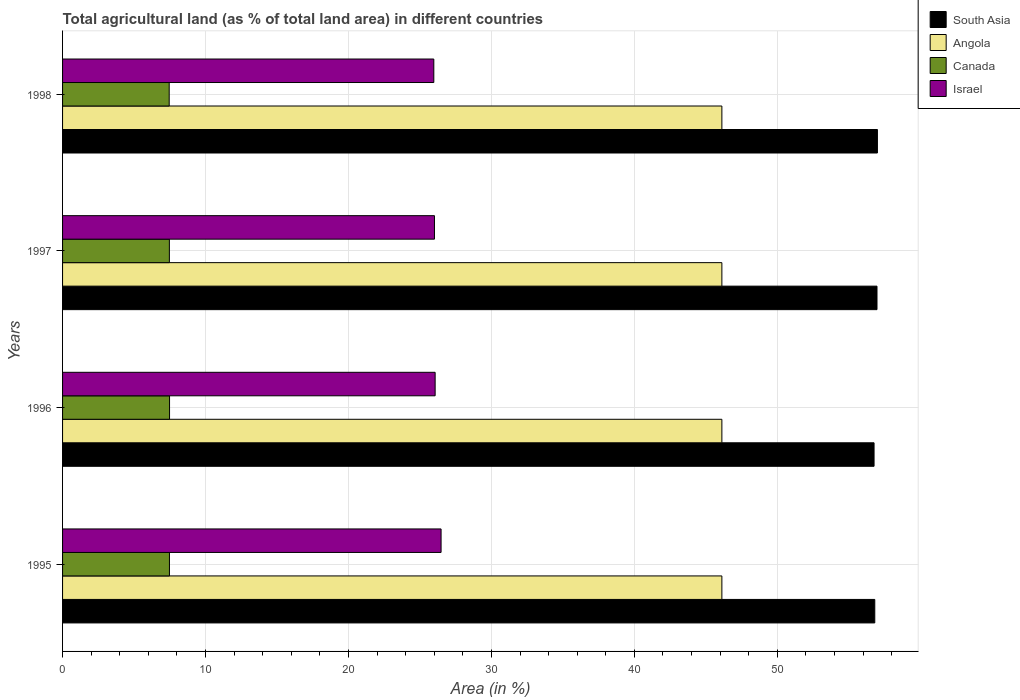How many different coloured bars are there?
Ensure brevity in your answer.  4. Are the number of bars per tick equal to the number of legend labels?
Offer a very short reply. Yes. How many bars are there on the 2nd tick from the top?
Make the answer very short. 4. In how many cases, is the number of bars for a given year not equal to the number of legend labels?
Give a very brief answer. 0. What is the percentage of agricultural land in Israel in 1995?
Your answer should be compact. 26.48. Across all years, what is the maximum percentage of agricultural land in Angola?
Make the answer very short. 46.12. Across all years, what is the minimum percentage of agricultural land in South Asia?
Ensure brevity in your answer.  56.77. In which year was the percentage of agricultural land in Angola maximum?
Keep it short and to the point. 1995. In which year was the percentage of agricultural land in Angola minimum?
Provide a short and direct response. 1995. What is the total percentage of agricultural land in Angola in the graph?
Give a very brief answer. 184.49. What is the difference between the percentage of agricultural land in Canada in 1996 and that in 1997?
Offer a very short reply. 0.01. What is the difference between the percentage of agricultural land in South Asia in 1995 and the percentage of agricultural land in Canada in 1997?
Ensure brevity in your answer.  49.35. What is the average percentage of agricultural land in Canada per year?
Offer a very short reply. 7.47. In the year 1997, what is the difference between the percentage of agricultural land in Israel and percentage of agricultural land in Canada?
Provide a succinct answer. 18.54. What is the difference between the highest and the second highest percentage of agricultural land in Israel?
Your response must be concise. 0.42. Does the graph contain any zero values?
Provide a short and direct response. No. Does the graph contain grids?
Give a very brief answer. Yes. Where does the legend appear in the graph?
Make the answer very short. Top right. What is the title of the graph?
Offer a terse response. Total agricultural land (as % of total land area) in different countries. What is the label or title of the X-axis?
Offer a terse response. Area (in %). What is the Area (in %) of South Asia in 1995?
Offer a very short reply. 56.82. What is the Area (in %) in Angola in 1995?
Give a very brief answer. 46.12. What is the Area (in %) in Canada in 1995?
Keep it short and to the point. 7.48. What is the Area (in %) of Israel in 1995?
Your answer should be very brief. 26.48. What is the Area (in %) of South Asia in 1996?
Offer a very short reply. 56.77. What is the Area (in %) of Angola in 1996?
Make the answer very short. 46.12. What is the Area (in %) in Canada in 1996?
Ensure brevity in your answer.  7.48. What is the Area (in %) in Israel in 1996?
Give a very brief answer. 26.06. What is the Area (in %) of South Asia in 1997?
Offer a very short reply. 56.97. What is the Area (in %) in Angola in 1997?
Offer a terse response. 46.12. What is the Area (in %) in Canada in 1997?
Offer a terse response. 7.47. What is the Area (in %) in Israel in 1997?
Your answer should be very brief. 26.02. What is the Area (in %) in South Asia in 1998?
Your answer should be compact. 57. What is the Area (in %) in Angola in 1998?
Provide a short and direct response. 46.12. What is the Area (in %) in Canada in 1998?
Your answer should be very brief. 7.46. What is the Area (in %) in Israel in 1998?
Make the answer very short. 25.97. Across all years, what is the maximum Area (in %) of South Asia?
Offer a terse response. 57. Across all years, what is the maximum Area (in %) in Angola?
Keep it short and to the point. 46.12. Across all years, what is the maximum Area (in %) in Canada?
Provide a succinct answer. 7.48. Across all years, what is the maximum Area (in %) of Israel?
Make the answer very short. 26.48. Across all years, what is the minimum Area (in %) in South Asia?
Offer a terse response. 56.77. Across all years, what is the minimum Area (in %) of Angola?
Your answer should be compact. 46.12. Across all years, what is the minimum Area (in %) in Canada?
Give a very brief answer. 7.46. Across all years, what is the minimum Area (in %) of Israel?
Offer a terse response. 25.97. What is the total Area (in %) in South Asia in the graph?
Provide a succinct answer. 227.56. What is the total Area (in %) of Angola in the graph?
Make the answer very short. 184.49. What is the total Area (in %) of Canada in the graph?
Make the answer very short. 29.89. What is the total Area (in %) in Israel in the graph?
Your response must be concise. 104.53. What is the difference between the Area (in %) in South Asia in 1995 and that in 1996?
Keep it short and to the point. 0.05. What is the difference between the Area (in %) in Canada in 1995 and that in 1996?
Ensure brevity in your answer.  -0.01. What is the difference between the Area (in %) of Israel in 1995 and that in 1996?
Offer a very short reply. 0.42. What is the difference between the Area (in %) in South Asia in 1995 and that in 1997?
Your answer should be very brief. -0.15. What is the difference between the Area (in %) of Angola in 1995 and that in 1997?
Offer a very short reply. 0. What is the difference between the Area (in %) in Canada in 1995 and that in 1997?
Offer a very short reply. 0.01. What is the difference between the Area (in %) of Israel in 1995 and that in 1997?
Provide a succinct answer. 0.46. What is the difference between the Area (in %) in South Asia in 1995 and that in 1998?
Keep it short and to the point. -0.18. What is the difference between the Area (in %) of Canada in 1995 and that in 1998?
Your answer should be compact. 0.02. What is the difference between the Area (in %) of Israel in 1995 and that in 1998?
Your response must be concise. 0.51. What is the difference between the Area (in %) in South Asia in 1996 and that in 1997?
Your answer should be very brief. -0.21. What is the difference between the Area (in %) in Canada in 1996 and that in 1997?
Your answer should be very brief. 0.01. What is the difference between the Area (in %) in Israel in 1996 and that in 1997?
Your answer should be compact. 0.05. What is the difference between the Area (in %) in South Asia in 1996 and that in 1998?
Provide a short and direct response. -0.23. What is the difference between the Area (in %) in Angola in 1996 and that in 1998?
Ensure brevity in your answer.  0. What is the difference between the Area (in %) of Canada in 1996 and that in 1998?
Your answer should be compact. 0.02. What is the difference between the Area (in %) in Israel in 1996 and that in 1998?
Keep it short and to the point. 0.09. What is the difference between the Area (in %) of South Asia in 1997 and that in 1998?
Ensure brevity in your answer.  -0.03. What is the difference between the Area (in %) in Canada in 1997 and that in 1998?
Provide a short and direct response. 0.01. What is the difference between the Area (in %) in Israel in 1997 and that in 1998?
Provide a short and direct response. 0.05. What is the difference between the Area (in %) of South Asia in 1995 and the Area (in %) of Angola in 1996?
Your answer should be compact. 10.7. What is the difference between the Area (in %) of South Asia in 1995 and the Area (in %) of Canada in 1996?
Your answer should be compact. 49.33. What is the difference between the Area (in %) of South Asia in 1995 and the Area (in %) of Israel in 1996?
Offer a terse response. 30.76. What is the difference between the Area (in %) of Angola in 1995 and the Area (in %) of Canada in 1996?
Give a very brief answer. 38.64. What is the difference between the Area (in %) in Angola in 1995 and the Area (in %) in Israel in 1996?
Your answer should be very brief. 20.06. What is the difference between the Area (in %) in Canada in 1995 and the Area (in %) in Israel in 1996?
Your answer should be very brief. -18.59. What is the difference between the Area (in %) of South Asia in 1995 and the Area (in %) of Angola in 1997?
Make the answer very short. 10.7. What is the difference between the Area (in %) of South Asia in 1995 and the Area (in %) of Canada in 1997?
Ensure brevity in your answer.  49.35. What is the difference between the Area (in %) of South Asia in 1995 and the Area (in %) of Israel in 1997?
Keep it short and to the point. 30.8. What is the difference between the Area (in %) of Angola in 1995 and the Area (in %) of Canada in 1997?
Your answer should be very brief. 38.65. What is the difference between the Area (in %) of Angola in 1995 and the Area (in %) of Israel in 1997?
Give a very brief answer. 20.11. What is the difference between the Area (in %) of Canada in 1995 and the Area (in %) of Israel in 1997?
Provide a succinct answer. -18.54. What is the difference between the Area (in %) of South Asia in 1995 and the Area (in %) of Angola in 1998?
Provide a succinct answer. 10.7. What is the difference between the Area (in %) of South Asia in 1995 and the Area (in %) of Canada in 1998?
Provide a short and direct response. 49.36. What is the difference between the Area (in %) of South Asia in 1995 and the Area (in %) of Israel in 1998?
Your answer should be compact. 30.85. What is the difference between the Area (in %) of Angola in 1995 and the Area (in %) of Canada in 1998?
Keep it short and to the point. 38.66. What is the difference between the Area (in %) in Angola in 1995 and the Area (in %) in Israel in 1998?
Give a very brief answer. 20.15. What is the difference between the Area (in %) of Canada in 1995 and the Area (in %) of Israel in 1998?
Offer a terse response. -18.49. What is the difference between the Area (in %) of South Asia in 1996 and the Area (in %) of Angola in 1997?
Offer a very short reply. 10.65. What is the difference between the Area (in %) in South Asia in 1996 and the Area (in %) in Canada in 1997?
Keep it short and to the point. 49.3. What is the difference between the Area (in %) of South Asia in 1996 and the Area (in %) of Israel in 1997?
Provide a short and direct response. 30.75. What is the difference between the Area (in %) of Angola in 1996 and the Area (in %) of Canada in 1997?
Your answer should be very brief. 38.65. What is the difference between the Area (in %) of Angola in 1996 and the Area (in %) of Israel in 1997?
Keep it short and to the point. 20.11. What is the difference between the Area (in %) in Canada in 1996 and the Area (in %) in Israel in 1997?
Give a very brief answer. -18.53. What is the difference between the Area (in %) in South Asia in 1996 and the Area (in %) in Angola in 1998?
Make the answer very short. 10.65. What is the difference between the Area (in %) of South Asia in 1996 and the Area (in %) of Canada in 1998?
Keep it short and to the point. 49.31. What is the difference between the Area (in %) of South Asia in 1996 and the Area (in %) of Israel in 1998?
Ensure brevity in your answer.  30.8. What is the difference between the Area (in %) of Angola in 1996 and the Area (in %) of Canada in 1998?
Your response must be concise. 38.66. What is the difference between the Area (in %) in Angola in 1996 and the Area (in %) in Israel in 1998?
Your answer should be very brief. 20.15. What is the difference between the Area (in %) in Canada in 1996 and the Area (in %) in Israel in 1998?
Offer a very short reply. -18.49. What is the difference between the Area (in %) in South Asia in 1997 and the Area (in %) in Angola in 1998?
Your answer should be very brief. 10.85. What is the difference between the Area (in %) in South Asia in 1997 and the Area (in %) in Canada in 1998?
Provide a succinct answer. 49.51. What is the difference between the Area (in %) of South Asia in 1997 and the Area (in %) of Israel in 1998?
Offer a terse response. 31. What is the difference between the Area (in %) of Angola in 1997 and the Area (in %) of Canada in 1998?
Make the answer very short. 38.66. What is the difference between the Area (in %) of Angola in 1997 and the Area (in %) of Israel in 1998?
Your answer should be compact. 20.15. What is the difference between the Area (in %) of Canada in 1997 and the Area (in %) of Israel in 1998?
Ensure brevity in your answer.  -18.5. What is the average Area (in %) of South Asia per year?
Give a very brief answer. 56.89. What is the average Area (in %) of Angola per year?
Provide a short and direct response. 46.12. What is the average Area (in %) in Canada per year?
Give a very brief answer. 7.47. What is the average Area (in %) of Israel per year?
Your response must be concise. 26.13. In the year 1995, what is the difference between the Area (in %) of South Asia and Area (in %) of Angola?
Your answer should be compact. 10.7. In the year 1995, what is the difference between the Area (in %) in South Asia and Area (in %) in Canada?
Your response must be concise. 49.34. In the year 1995, what is the difference between the Area (in %) in South Asia and Area (in %) in Israel?
Provide a succinct answer. 30.34. In the year 1995, what is the difference between the Area (in %) of Angola and Area (in %) of Canada?
Keep it short and to the point. 38.64. In the year 1995, what is the difference between the Area (in %) of Angola and Area (in %) of Israel?
Make the answer very short. 19.64. In the year 1995, what is the difference between the Area (in %) in Canada and Area (in %) in Israel?
Your answer should be compact. -19. In the year 1996, what is the difference between the Area (in %) of South Asia and Area (in %) of Angola?
Your answer should be compact. 10.65. In the year 1996, what is the difference between the Area (in %) of South Asia and Area (in %) of Canada?
Make the answer very short. 49.28. In the year 1996, what is the difference between the Area (in %) in South Asia and Area (in %) in Israel?
Ensure brevity in your answer.  30.7. In the year 1996, what is the difference between the Area (in %) in Angola and Area (in %) in Canada?
Your answer should be very brief. 38.64. In the year 1996, what is the difference between the Area (in %) in Angola and Area (in %) in Israel?
Keep it short and to the point. 20.06. In the year 1996, what is the difference between the Area (in %) of Canada and Area (in %) of Israel?
Offer a very short reply. -18.58. In the year 1997, what is the difference between the Area (in %) of South Asia and Area (in %) of Angola?
Provide a succinct answer. 10.85. In the year 1997, what is the difference between the Area (in %) in South Asia and Area (in %) in Canada?
Your answer should be very brief. 49.5. In the year 1997, what is the difference between the Area (in %) in South Asia and Area (in %) in Israel?
Ensure brevity in your answer.  30.96. In the year 1997, what is the difference between the Area (in %) of Angola and Area (in %) of Canada?
Your response must be concise. 38.65. In the year 1997, what is the difference between the Area (in %) of Angola and Area (in %) of Israel?
Your answer should be compact. 20.11. In the year 1997, what is the difference between the Area (in %) in Canada and Area (in %) in Israel?
Offer a very short reply. -18.54. In the year 1998, what is the difference between the Area (in %) of South Asia and Area (in %) of Angola?
Provide a succinct answer. 10.88. In the year 1998, what is the difference between the Area (in %) in South Asia and Area (in %) in Canada?
Offer a very short reply. 49.54. In the year 1998, what is the difference between the Area (in %) of South Asia and Area (in %) of Israel?
Your answer should be compact. 31.03. In the year 1998, what is the difference between the Area (in %) of Angola and Area (in %) of Canada?
Your answer should be very brief. 38.66. In the year 1998, what is the difference between the Area (in %) of Angola and Area (in %) of Israel?
Ensure brevity in your answer.  20.15. In the year 1998, what is the difference between the Area (in %) in Canada and Area (in %) in Israel?
Provide a succinct answer. -18.51. What is the ratio of the Area (in %) in South Asia in 1995 to that in 1996?
Keep it short and to the point. 1. What is the ratio of the Area (in %) in Angola in 1995 to that in 1996?
Ensure brevity in your answer.  1. What is the ratio of the Area (in %) in Canada in 1995 to that in 1996?
Provide a succinct answer. 1. What is the ratio of the Area (in %) in Angola in 1995 to that in 1997?
Give a very brief answer. 1. What is the ratio of the Area (in %) in Canada in 1995 to that in 1997?
Provide a succinct answer. 1. What is the ratio of the Area (in %) of Israel in 1995 to that in 1997?
Ensure brevity in your answer.  1.02. What is the ratio of the Area (in %) of Canada in 1995 to that in 1998?
Keep it short and to the point. 1. What is the ratio of the Area (in %) of Israel in 1995 to that in 1998?
Your response must be concise. 1.02. What is the ratio of the Area (in %) in Israel in 1996 to that in 1997?
Your answer should be very brief. 1. What is the ratio of the Area (in %) in Israel in 1996 to that in 1998?
Ensure brevity in your answer.  1. What is the ratio of the Area (in %) in South Asia in 1997 to that in 1998?
Ensure brevity in your answer.  1. What is the ratio of the Area (in %) in Angola in 1997 to that in 1998?
Ensure brevity in your answer.  1. What is the ratio of the Area (in %) in Canada in 1997 to that in 1998?
Your response must be concise. 1. What is the ratio of the Area (in %) of Israel in 1997 to that in 1998?
Your response must be concise. 1. What is the difference between the highest and the second highest Area (in %) of South Asia?
Offer a terse response. 0.03. What is the difference between the highest and the second highest Area (in %) of Canada?
Make the answer very short. 0.01. What is the difference between the highest and the second highest Area (in %) in Israel?
Provide a short and direct response. 0.42. What is the difference between the highest and the lowest Area (in %) in South Asia?
Offer a very short reply. 0.23. What is the difference between the highest and the lowest Area (in %) in Canada?
Provide a short and direct response. 0.02. What is the difference between the highest and the lowest Area (in %) in Israel?
Offer a terse response. 0.51. 